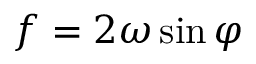Convert formula to latex. <formula><loc_0><loc_0><loc_500><loc_500>f = 2 \omega \sin \varphi</formula> 